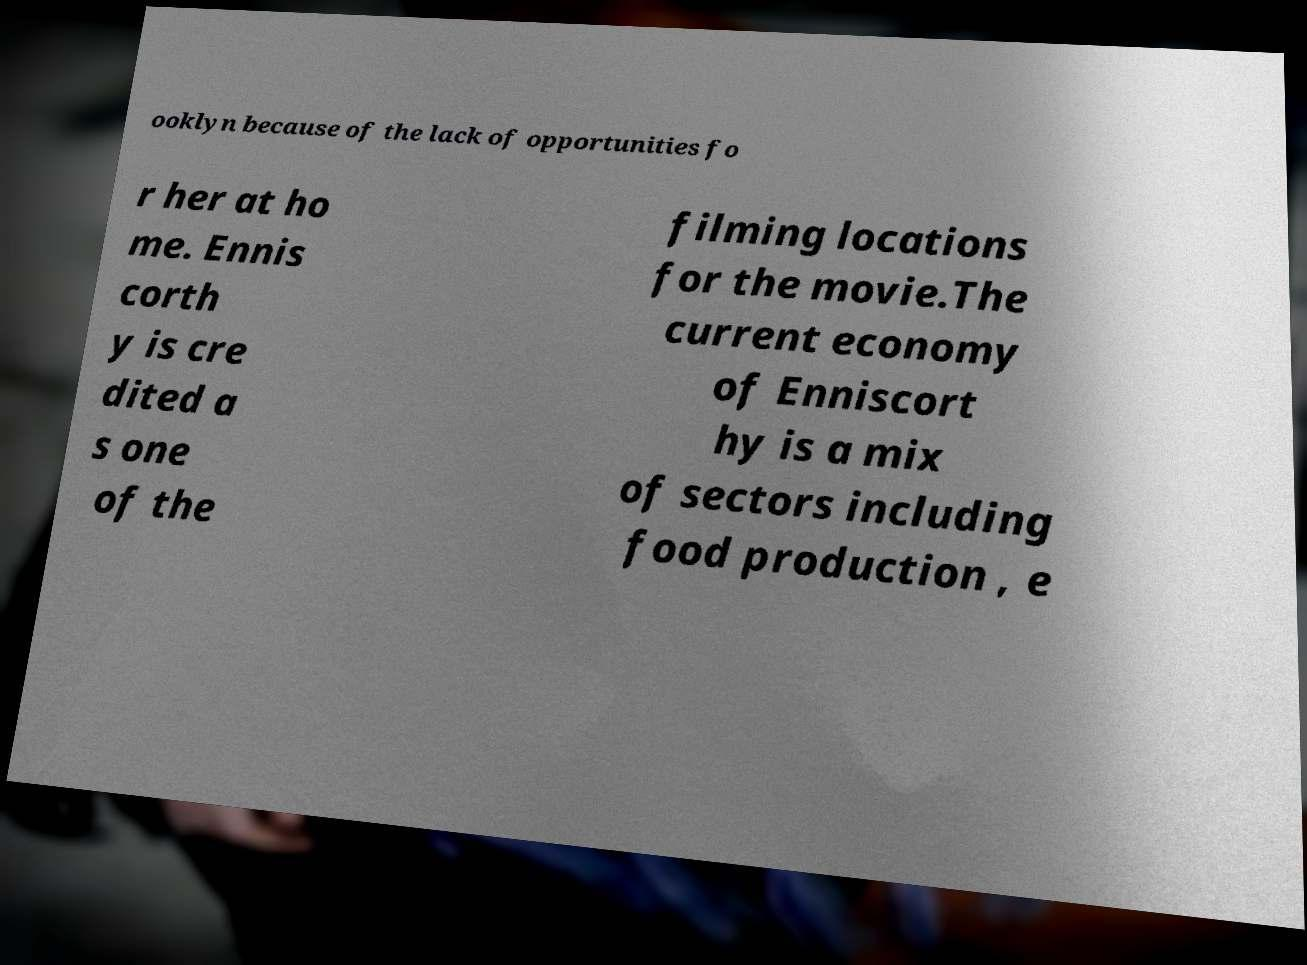Please identify and transcribe the text found in this image. ooklyn because of the lack of opportunities fo r her at ho me. Ennis corth y is cre dited a s one of the filming locations for the movie.The current economy of Enniscort hy is a mix of sectors including food production , e 